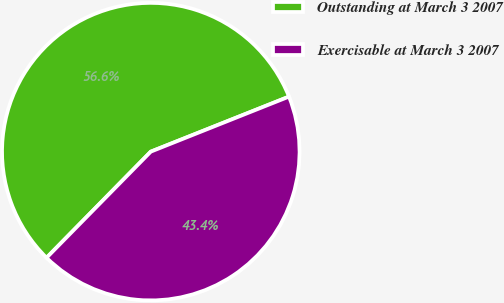Convert chart to OTSL. <chart><loc_0><loc_0><loc_500><loc_500><pie_chart><fcel>Outstanding at March 3 2007<fcel>Exercisable at March 3 2007<nl><fcel>56.61%<fcel>43.39%<nl></chart> 